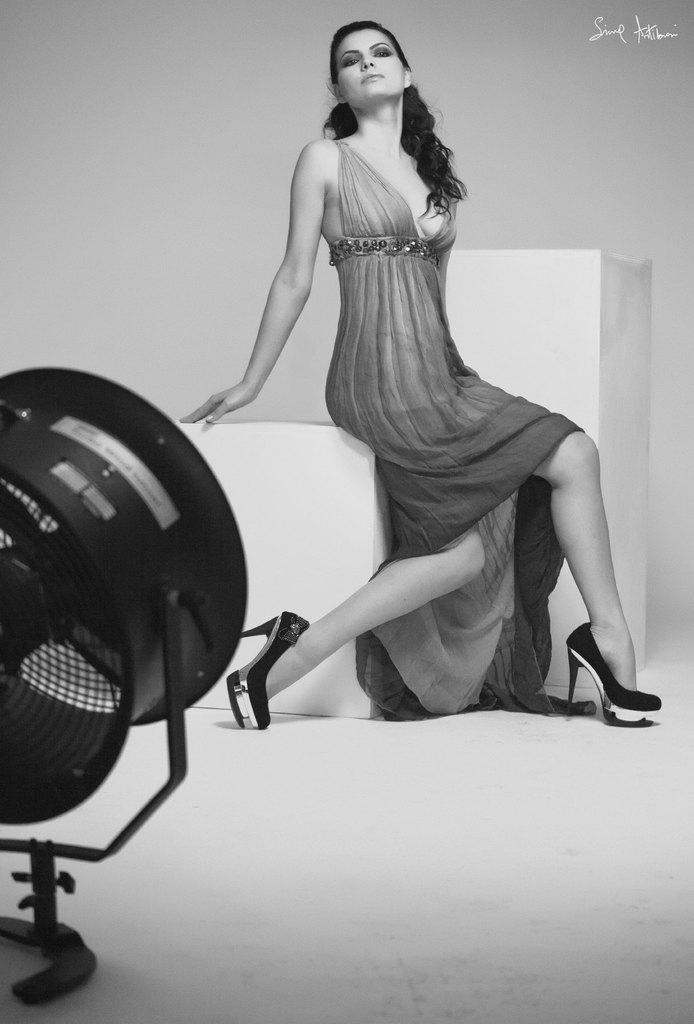Please provide a concise description of this image. In this picture there is a woman sitting. In the foreground there is a fan. In the top right there is a text. This picture is an edited picture. 